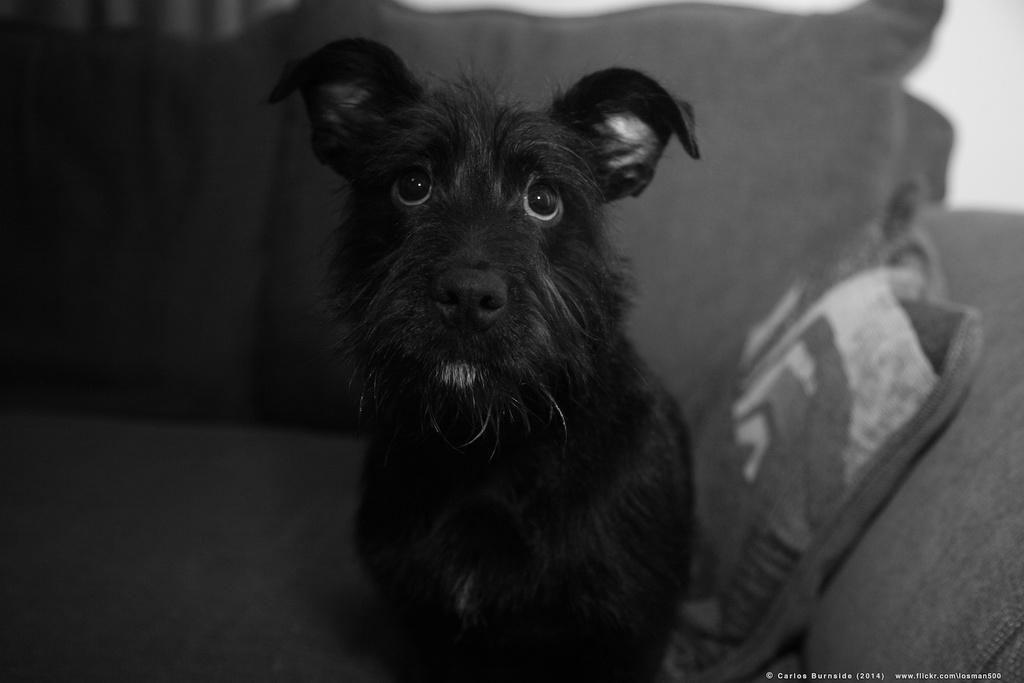In one or two sentences, can you explain what this image depicts? This is a black and white picture. Here we can see a dog on the sofa and there is a pillow. 